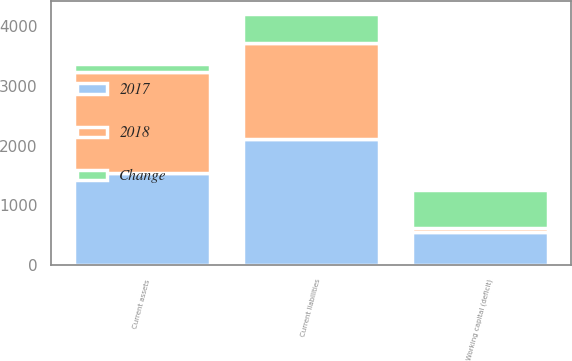Convert chart to OTSL. <chart><loc_0><loc_0><loc_500><loc_500><stacked_bar_chart><ecel><fcel>Current assets<fcel>Current liabilities<fcel>Working capital (deficit)<nl><fcel>2017<fcel>1543.8<fcel>2102.4<fcel>558.6<nl><fcel>2018<fcel>1682.6<fcel>1614.1<fcel>68.5<nl><fcel>Change<fcel>138.8<fcel>488.3<fcel>627.1<nl></chart> 